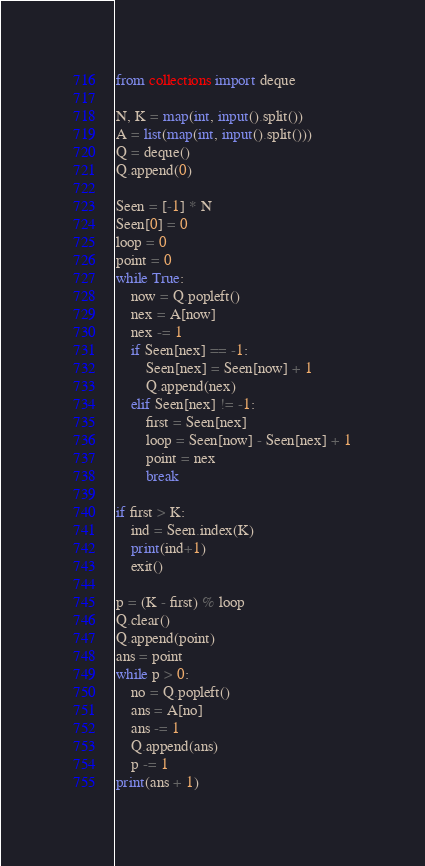Convert code to text. <code><loc_0><loc_0><loc_500><loc_500><_Python_>from collections import deque

N, K = map(int, input().split())
A = list(map(int, input().split()))
Q = deque()
Q.append(0)

Seen = [-1] * N
Seen[0] = 0
loop = 0
point = 0
while True:
    now = Q.popleft()
    nex = A[now]
    nex -= 1
    if Seen[nex] == -1:
        Seen[nex] = Seen[now] + 1
        Q.append(nex)
    elif Seen[nex] != -1:
        first = Seen[nex]
        loop = Seen[now] - Seen[nex] + 1
        point = nex
        break

if first > K:
    ind = Seen.index(K)
    print(ind+1)
    exit()

p = (K - first) % loop
Q.clear()
Q.append(point)
ans = point
while p > 0:
    no = Q.popleft()
    ans = A[no]
    ans -= 1
    Q.append(ans)
    p -= 1
print(ans + 1)

</code> 